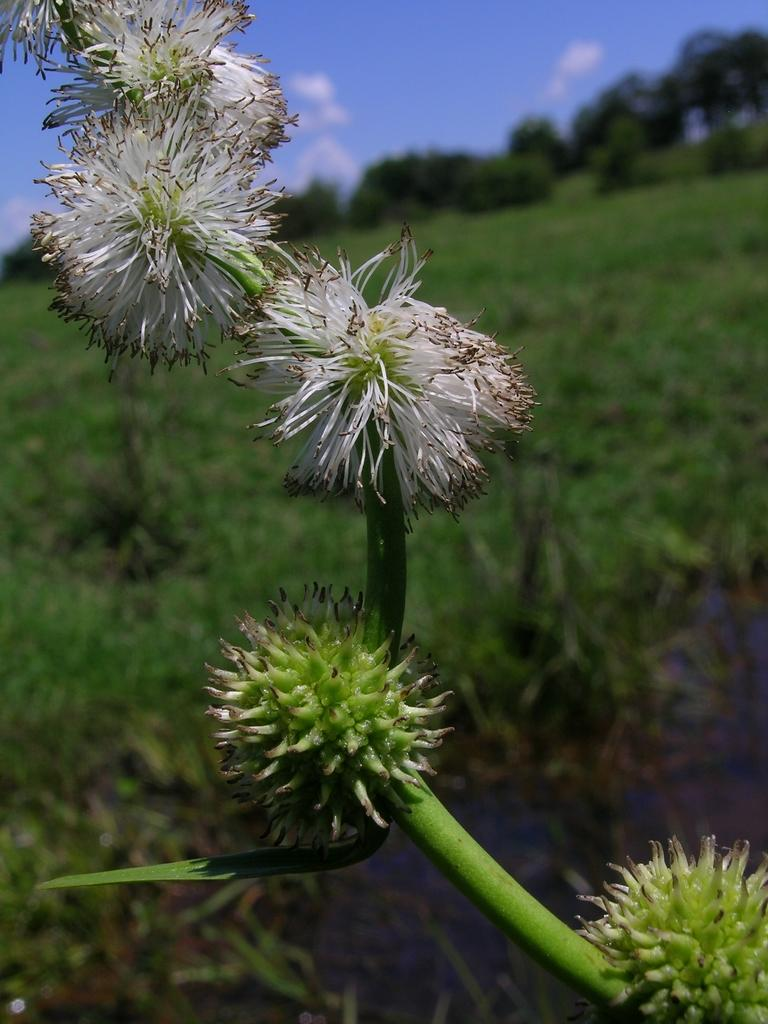What is present on the stem of the plant in the image? There are flowers on the stem of a plant in the image. What else can be seen in the image besides the plant with flowers? There are plants and a group of trees visible in the background of the image. What is visible in the background of the image beyond the plants and trees? The sky is visible in the background of the image. How would you describe the sky in the image? The sky appears cloudy in the image. What type of gold object is hanging from the tree in the image? There is no gold object present in the image; it features a plant with flowers, plants and trees in the background, and a cloudy sky. 